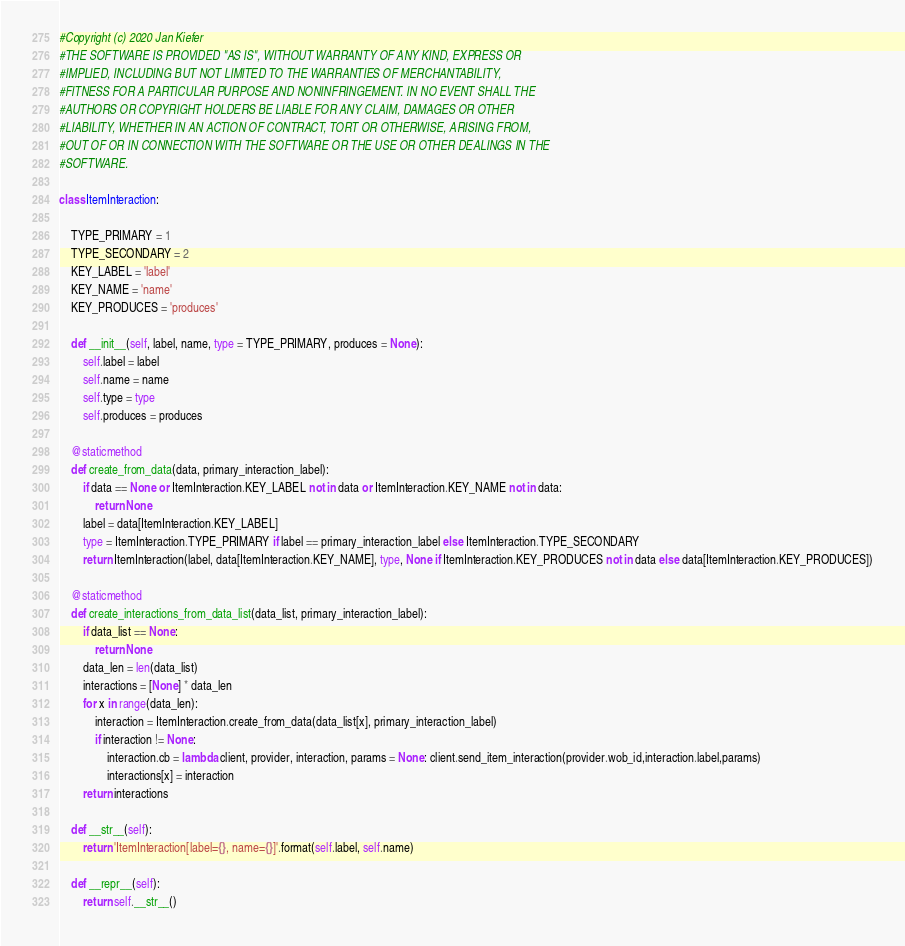<code> <loc_0><loc_0><loc_500><loc_500><_Python_>#Copyright (c) 2020 Jan Kiefer
#THE SOFTWARE IS PROVIDED "AS IS", WITHOUT WARRANTY OF ANY KIND, EXPRESS OR
#IMPLIED, INCLUDING BUT NOT LIMITED TO THE WARRANTIES OF MERCHANTABILITY,
#FITNESS FOR A PARTICULAR PURPOSE AND NONINFRINGEMENT. IN NO EVENT SHALL THE
#AUTHORS OR COPYRIGHT HOLDERS BE LIABLE FOR ANY CLAIM, DAMAGES OR OTHER
#LIABILITY, WHETHER IN AN ACTION OF CONTRACT, TORT OR OTHERWISE, ARISING FROM,
#OUT OF OR IN CONNECTION WITH THE SOFTWARE OR THE USE OR OTHER DEALINGS IN THE
#SOFTWARE.

class ItemInteraction:
	
	TYPE_PRIMARY = 1
	TYPE_SECONDARY = 2
	KEY_LABEL = 'label'
	KEY_NAME = 'name'
	KEY_PRODUCES = 'produces'
	
	def __init__(self, label, name, type = TYPE_PRIMARY, produces = None):
		self.label = label
		self.name = name
		self.type = type
		self.produces = produces
		
	@staticmethod
	def create_from_data(data, primary_interaction_label):
		if data == None or ItemInteraction.KEY_LABEL not in data or ItemInteraction.KEY_NAME not in data:
			return None
		label = data[ItemInteraction.KEY_LABEL]
		type = ItemInteraction.TYPE_PRIMARY if label == primary_interaction_label else ItemInteraction.TYPE_SECONDARY
		return ItemInteraction(label, data[ItemInteraction.KEY_NAME], type, None if ItemInteraction.KEY_PRODUCES not in data else data[ItemInteraction.KEY_PRODUCES])
	
	@staticmethod
	def create_interactions_from_data_list(data_list, primary_interaction_label):
		if data_list == None:
			return None
		data_len = len(data_list)
		interactions = [None] * data_len
		for x in range(data_len):
			interaction = ItemInteraction.create_from_data(data_list[x], primary_interaction_label)
			if interaction != None:
				interaction.cb = lambda client, provider, interaction, params = None: client.send_item_interaction(provider.wob_id,interaction.label,params)
				interactions[x] = interaction
		return interactions
		
	def __str__(self):
		return 'ItemInteraction[label={}, name={}]'.format(self.label, self.name)
	
	def __repr__(self):
		return self.__str__()</code> 